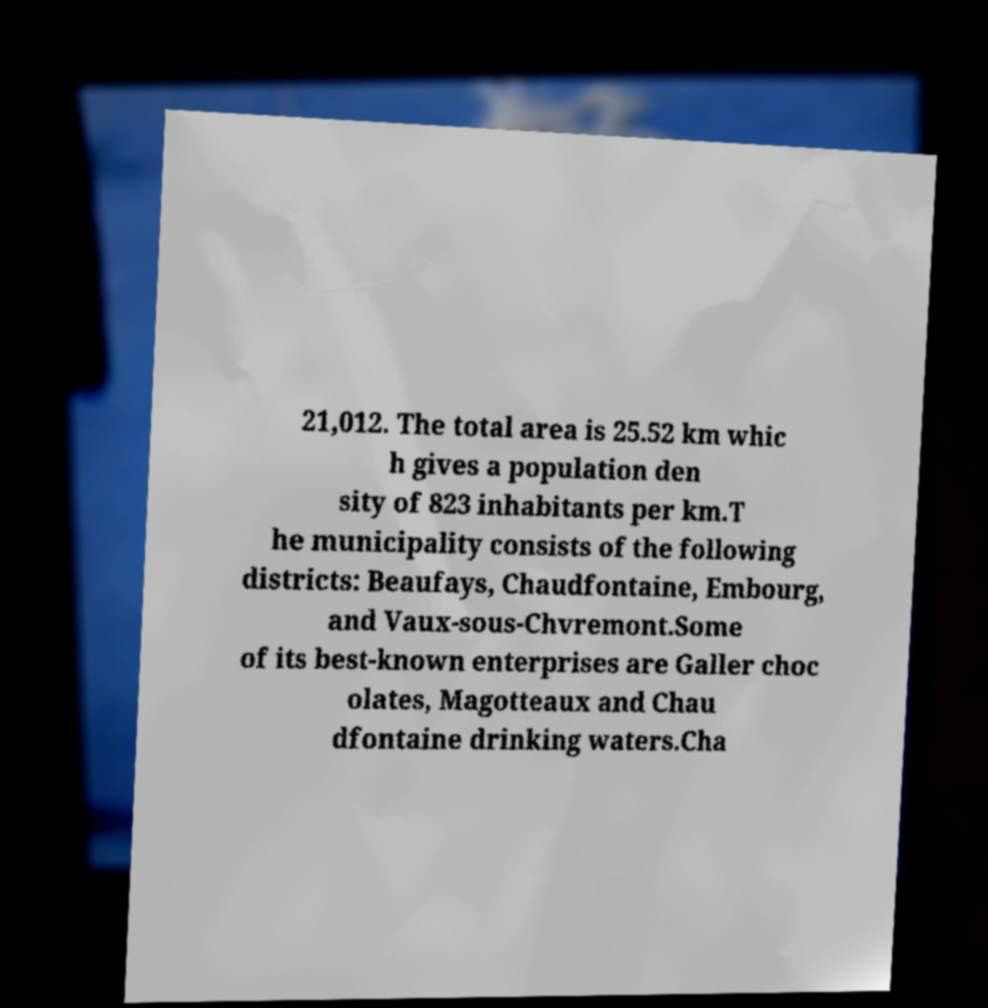Could you extract and type out the text from this image? 21,012. The total area is 25.52 km whic h gives a population den sity of 823 inhabitants per km.T he municipality consists of the following districts: Beaufays, Chaudfontaine, Embourg, and Vaux-sous-Chvremont.Some of its best-known enterprises are Galler choc olates, Magotteaux and Chau dfontaine drinking waters.Cha 